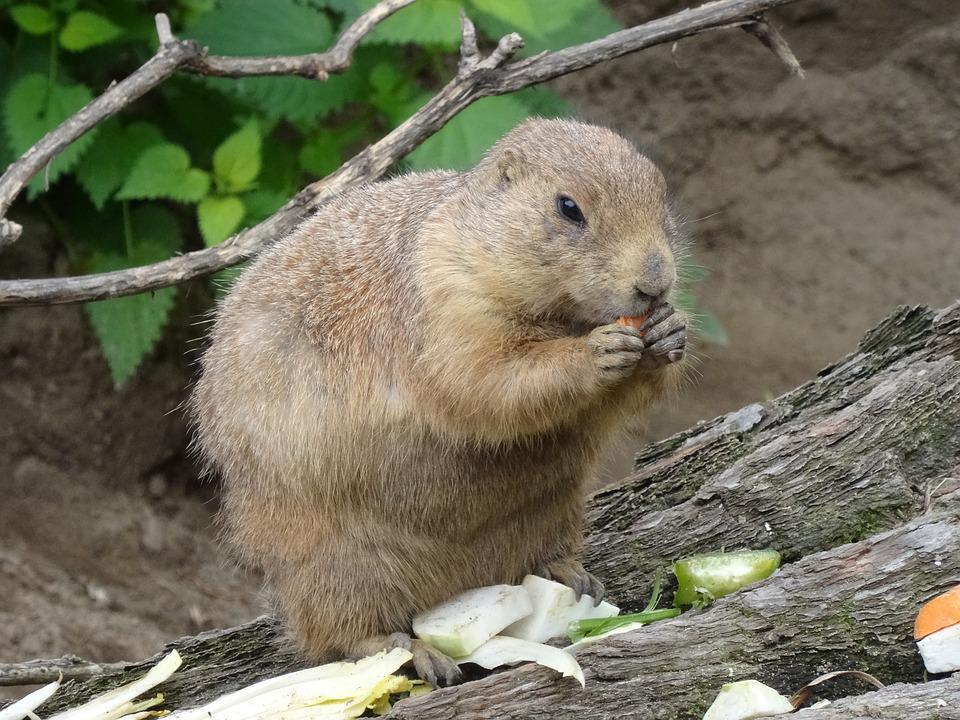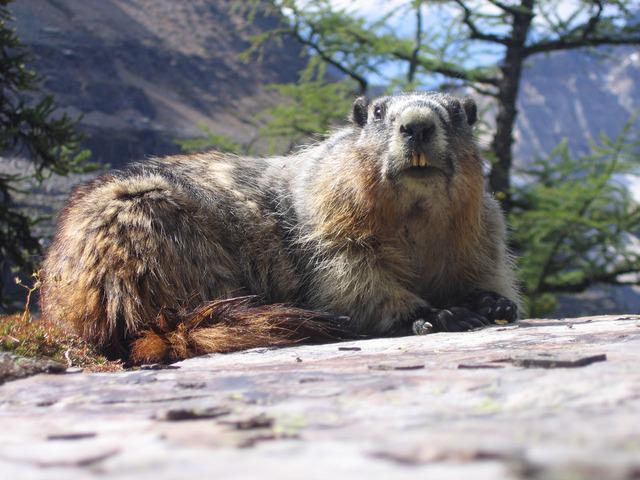The first image is the image on the left, the second image is the image on the right. Given the left and right images, does the statement "An image features an upright marmot with something clasped in its paws at mouth-level." hold true? Answer yes or no. Yes. The first image is the image on the left, the second image is the image on the right. Considering the images on both sides, is "The animal in the image on  the right is standing on its hind legs." valid? Answer yes or no. No. 